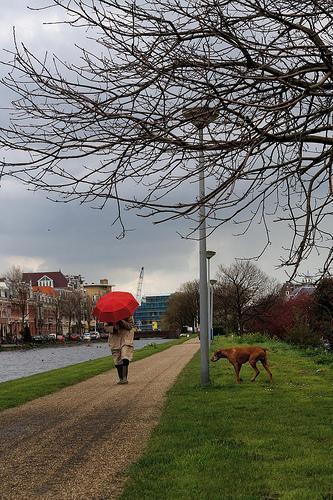How many dogs are prominently pictured?
Give a very brief answer. 1. How many legs does the dog have?
Give a very brief answer. 4. 